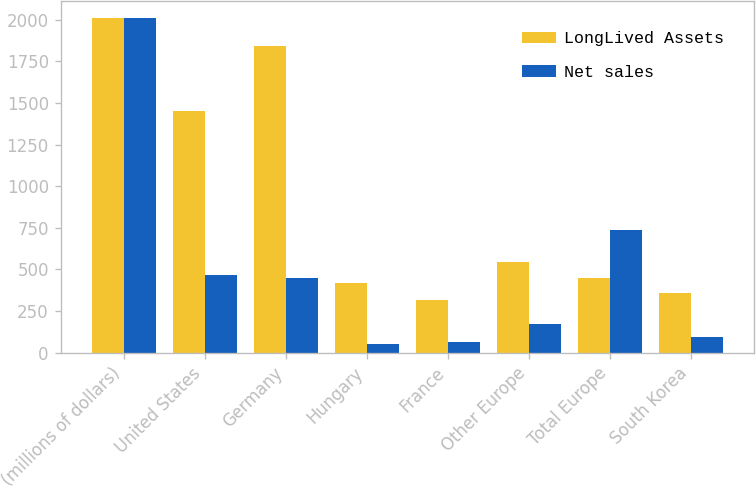Convert chart to OTSL. <chart><loc_0><loc_0><loc_500><loc_500><stacked_bar_chart><ecel><fcel>(millions of dollars)<fcel>United States<fcel>Germany<fcel>Hungary<fcel>France<fcel>Other Europe<fcel>Total Europe<fcel>South Korea<nl><fcel>LongLived Assets<fcel>2010<fcel>1451.1<fcel>1839.9<fcel>418.3<fcel>318.7<fcel>546.1<fcel>447.5<fcel>358<nl><fcel>Net sales<fcel>2010<fcel>466.6<fcel>447.5<fcel>53<fcel>63<fcel>173.7<fcel>737.2<fcel>94.8<nl></chart> 